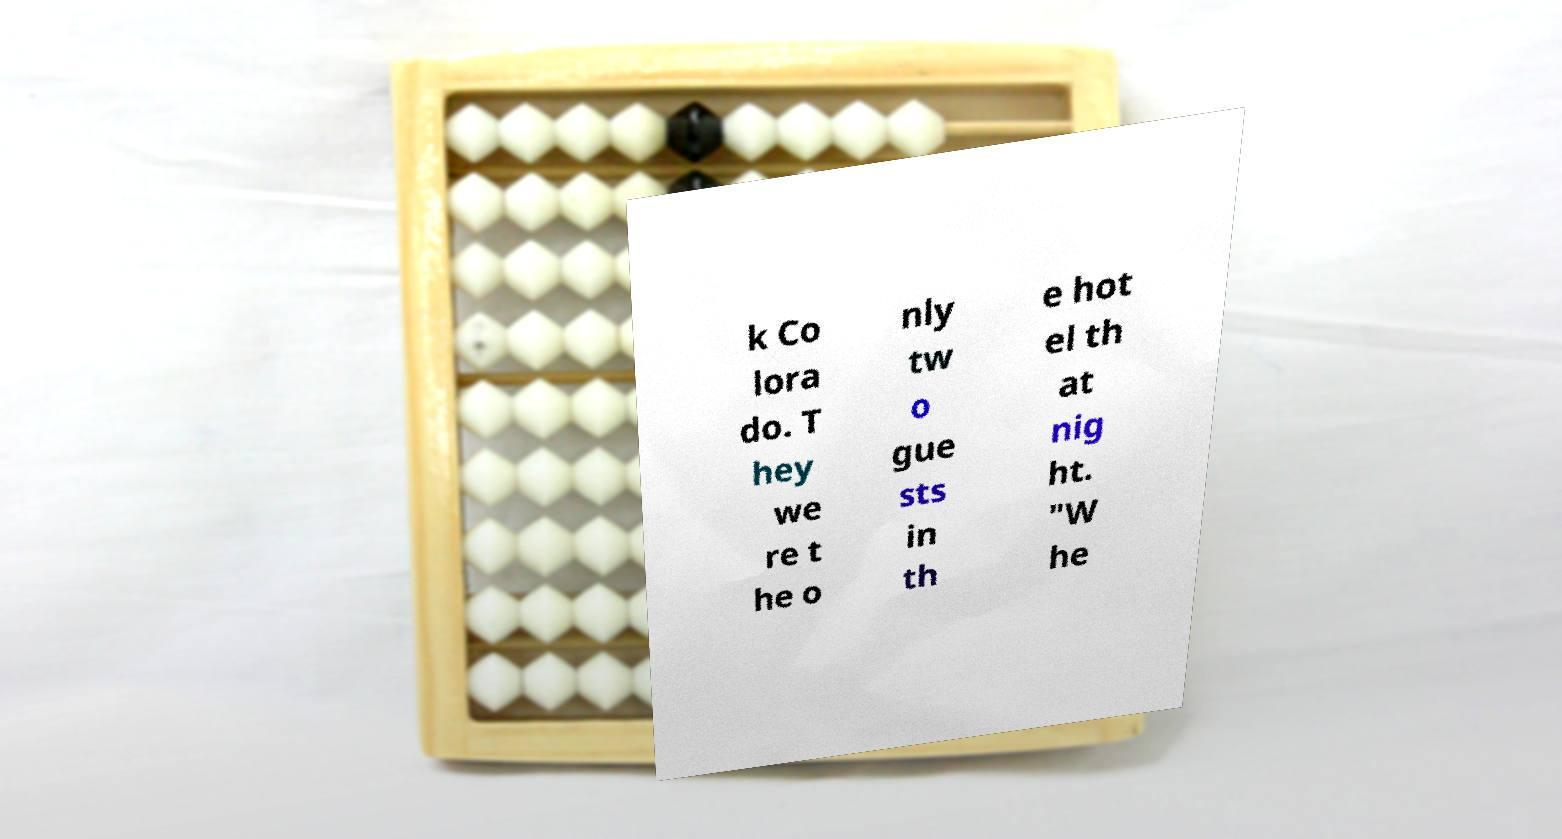Can you read and provide the text displayed in the image?This photo seems to have some interesting text. Can you extract and type it out for me? k Co lora do. T hey we re t he o nly tw o gue sts in th e hot el th at nig ht. "W he 